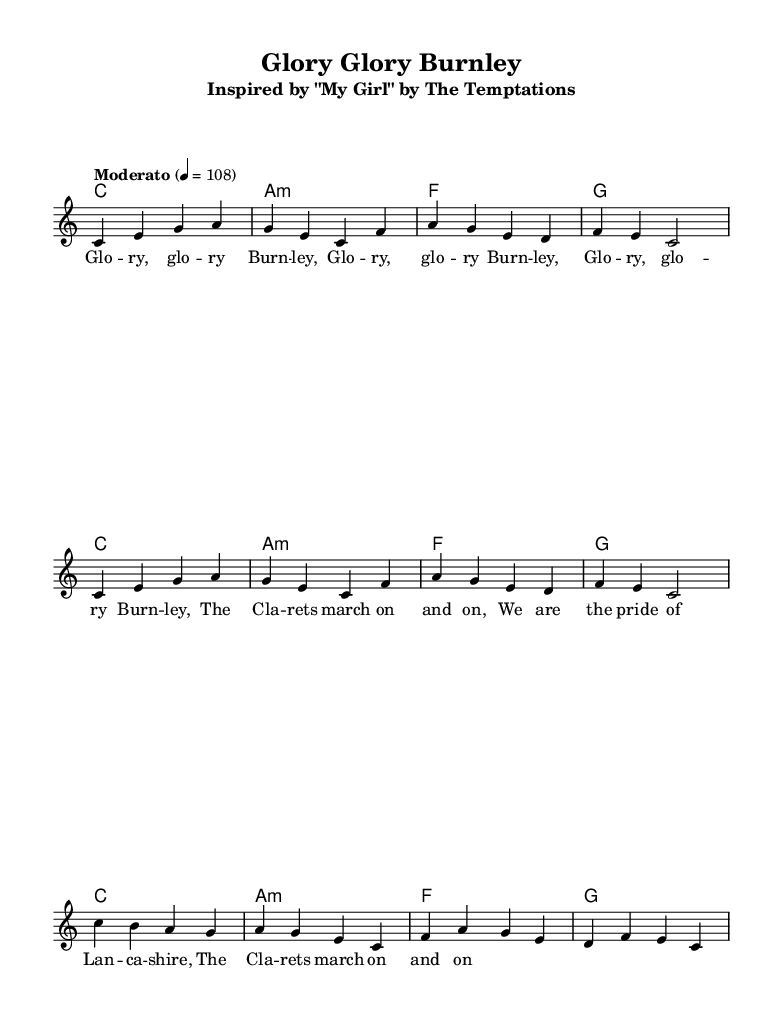What is the key signature of this music? The key signature is indicated at the start of the sheet music, showing no sharps or flats. This means it is in C major.
Answer: C major What is the time signature of the piece? The time signature is found at the beginning of the sheet music, indicating that each measure contains four beats. This is represented as 4/4.
Answer: 4/4 What is the tempo marking for this piece? The tempo marking appears in the header section stating "Moderato," along with the metronome mark of 108. This suggests a moderate pace.
Answer: Moderato How many measures are there in the melody? By counting the measures in the melody section, we see there are eight distinct measures. This can be verified visually on the staff.
Answer: 8 What is the main chord progression used in the music? The chord progression is listed in the harmonies section, showing a repeated sequence of C major, A minor, F major, and G major chords. This is typical of many pop and soul songs.
Answer: C, A minor, F, G What is the lyrical theme of the song? The lyrics are provided alongside the melody and convey a sense of pride and celebration associated with a football club, specifically Burnley. The repeated phrase emphasizes glory.
Answer: Glory, glory Burnley 